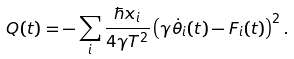Convert formula to latex. <formula><loc_0><loc_0><loc_500><loc_500>Q ( t ) = - \sum _ { i } \frac { \hbar { x } _ { i } } { 4 \gamma T ^ { 2 } } \left ( \gamma \dot { \theta } _ { i } ( t ) - F _ { i } ( t ) \right ) ^ { 2 } .</formula> 